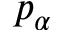Convert formula to latex. <formula><loc_0><loc_0><loc_500><loc_500>p _ { \alpha }</formula> 